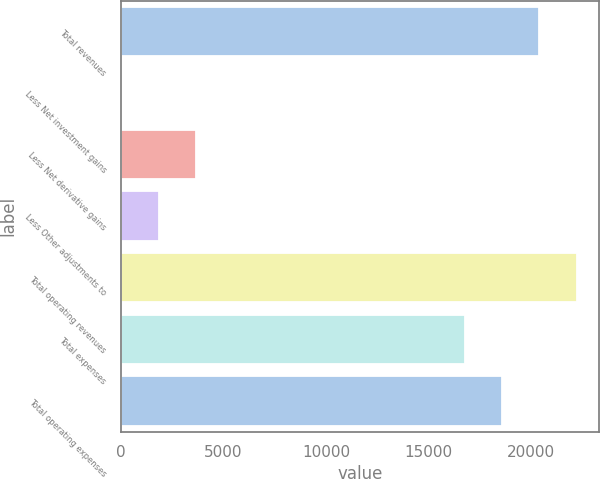Convert chart to OTSL. <chart><loc_0><loc_0><loc_500><loc_500><bar_chart><fcel>Total revenues<fcel>Less Net investment gains<fcel>Less Net derivative gains<fcel>Less Other adjustments to<fcel>Total operating revenues<fcel>Total expenses<fcel>Total operating expenses<nl><fcel>20400.2<fcel>21<fcel>3659.2<fcel>1840.1<fcel>22219.3<fcel>16762<fcel>18581.1<nl></chart> 